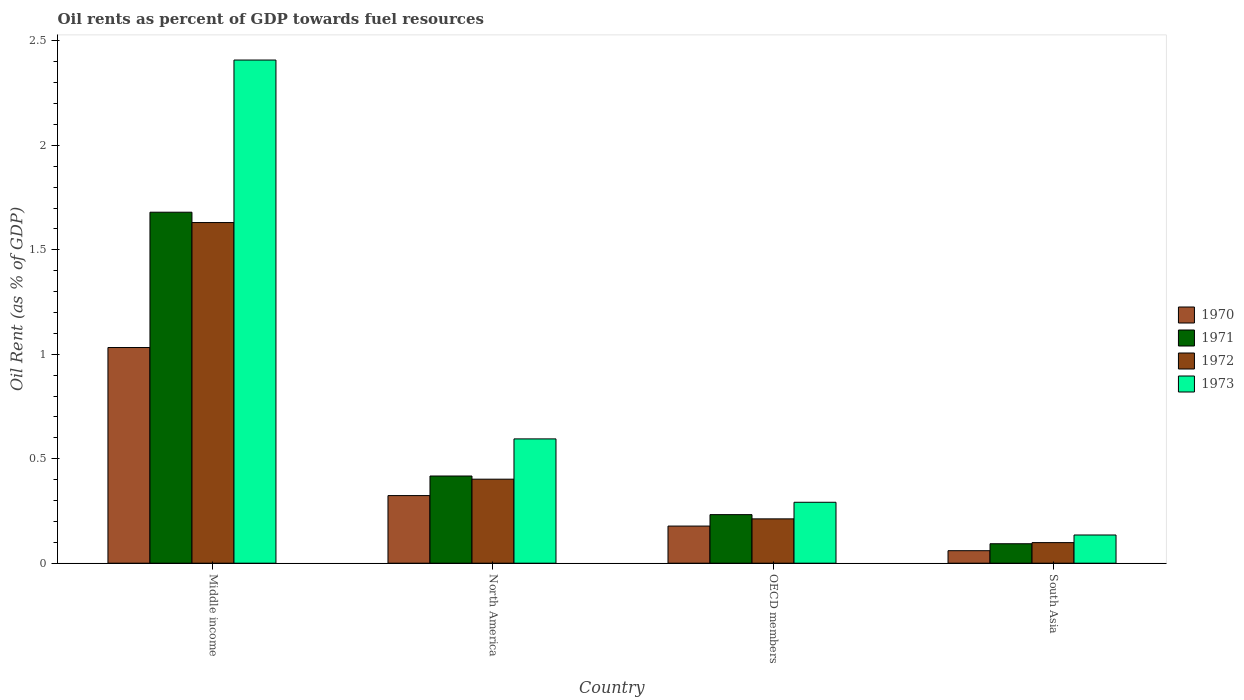Are the number of bars per tick equal to the number of legend labels?
Ensure brevity in your answer.  Yes. Are the number of bars on each tick of the X-axis equal?
Keep it short and to the point. Yes. How many bars are there on the 1st tick from the left?
Your response must be concise. 4. In how many cases, is the number of bars for a given country not equal to the number of legend labels?
Your response must be concise. 0. What is the oil rent in 1972 in North America?
Your answer should be compact. 0.4. Across all countries, what is the maximum oil rent in 1973?
Keep it short and to the point. 2.41. Across all countries, what is the minimum oil rent in 1972?
Make the answer very short. 0.1. In which country was the oil rent in 1973 maximum?
Keep it short and to the point. Middle income. In which country was the oil rent in 1973 minimum?
Provide a succinct answer. South Asia. What is the total oil rent in 1971 in the graph?
Your response must be concise. 2.42. What is the difference between the oil rent in 1973 in OECD members and that in South Asia?
Offer a terse response. 0.16. What is the difference between the oil rent in 1973 in North America and the oil rent in 1972 in South Asia?
Your answer should be very brief. 0.5. What is the average oil rent in 1972 per country?
Make the answer very short. 0.59. What is the difference between the oil rent of/in 1970 and oil rent of/in 1971 in North America?
Your response must be concise. -0.09. What is the ratio of the oil rent in 1973 in Middle income to that in South Asia?
Keep it short and to the point. 17.84. Is the difference between the oil rent in 1970 in OECD members and South Asia greater than the difference between the oil rent in 1971 in OECD members and South Asia?
Keep it short and to the point. No. What is the difference between the highest and the second highest oil rent in 1970?
Make the answer very short. -0.71. What is the difference between the highest and the lowest oil rent in 1970?
Provide a succinct answer. 0.97. Is the sum of the oil rent in 1971 in Middle income and North America greater than the maximum oil rent in 1973 across all countries?
Offer a very short reply. No. Is it the case that in every country, the sum of the oil rent in 1972 and oil rent in 1970 is greater than the oil rent in 1973?
Give a very brief answer. Yes. What is the difference between two consecutive major ticks on the Y-axis?
Ensure brevity in your answer.  0.5. Are the values on the major ticks of Y-axis written in scientific E-notation?
Ensure brevity in your answer.  No. What is the title of the graph?
Your answer should be compact. Oil rents as percent of GDP towards fuel resources. Does "1983" appear as one of the legend labels in the graph?
Give a very brief answer. No. What is the label or title of the X-axis?
Your answer should be compact. Country. What is the label or title of the Y-axis?
Your response must be concise. Oil Rent (as % of GDP). What is the Oil Rent (as % of GDP) of 1970 in Middle income?
Give a very brief answer. 1.03. What is the Oil Rent (as % of GDP) in 1971 in Middle income?
Provide a short and direct response. 1.68. What is the Oil Rent (as % of GDP) of 1972 in Middle income?
Keep it short and to the point. 1.63. What is the Oil Rent (as % of GDP) in 1973 in Middle income?
Give a very brief answer. 2.41. What is the Oil Rent (as % of GDP) of 1970 in North America?
Ensure brevity in your answer.  0.32. What is the Oil Rent (as % of GDP) of 1971 in North America?
Your answer should be compact. 0.42. What is the Oil Rent (as % of GDP) of 1972 in North America?
Keep it short and to the point. 0.4. What is the Oil Rent (as % of GDP) in 1973 in North America?
Your answer should be compact. 0.6. What is the Oil Rent (as % of GDP) in 1970 in OECD members?
Give a very brief answer. 0.18. What is the Oil Rent (as % of GDP) of 1971 in OECD members?
Your answer should be compact. 0.23. What is the Oil Rent (as % of GDP) of 1972 in OECD members?
Keep it short and to the point. 0.21. What is the Oil Rent (as % of GDP) of 1973 in OECD members?
Keep it short and to the point. 0.29. What is the Oil Rent (as % of GDP) in 1970 in South Asia?
Your answer should be very brief. 0.06. What is the Oil Rent (as % of GDP) in 1971 in South Asia?
Offer a very short reply. 0.09. What is the Oil Rent (as % of GDP) in 1972 in South Asia?
Keep it short and to the point. 0.1. What is the Oil Rent (as % of GDP) of 1973 in South Asia?
Provide a succinct answer. 0.14. Across all countries, what is the maximum Oil Rent (as % of GDP) of 1970?
Your answer should be very brief. 1.03. Across all countries, what is the maximum Oil Rent (as % of GDP) in 1971?
Make the answer very short. 1.68. Across all countries, what is the maximum Oil Rent (as % of GDP) of 1972?
Offer a terse response. 1.63. Across all countries, what is the maximum Oil Rent (as % of GDP) in 1973?
Provide a succinct answer. 2.41. Across all countries, what is the minimum Oil Rent (as % of GDP) of 1970?
Make the answer very short. 0.06. Across all countries, what is the minimum Oil Rent (as % of GDP) of 1971?
Give a very brief answer. 0.09. Across all countries, what is the minimum Oil Rent (as % of GDP) in 1972?
Make the answer very short. 0.1. Across all countries, what is the minimum Oil Rent (as % of GDP) in 1973?
Provide a succinct answer. 0.14. What is the total Oil Rent (as % of GDP) in 1970 in the graph?
Offer a terse response. 1.59. What is the total Oil Rent (as % of GDP) in 1971 in the graph?
Give a very brief answer. 2.42. What is the total Oil Rent (as % of GDP) in 1972 in the graph?
Make the answer very short. 2.34. What is the total Oil Rent (as % of GDP) of 1973 in the graph?
Your answer should be compact. 3.43. What is the difference between the Oil Rent (as % of GDP) in 1970 in Middle income and that in North America?
Your answer should be compact. 0.71. What is the difference between the Oil Rent (as % of GDP) in 1971 in Middle income and that in North America?
Provide a succinct answer. 1.26. What is the difference between the Oil Rent (as % of GDP) of 1972 in Middle income and that in North America?
Offer a very short reply. 1.23. What is the difference between the Oil Rent (as % of GDP) of 1973 in Middle income and that in North America?
Provide a short and direct response. 1.81. What is the difference between the Oil Rent (as % of GDP) in 1970 in Middle income and that in OECD members?
Ensure brevity in your answer.  0.85. What is the difference between the Oil Rent (as % of GDP) in 1971 in Middle income and that in OECD members?
Provide a succinct answer. 1.45. What is the difference between the Oil Rent (as % of GDP) of 1972 in Middle income and that in OECD members?
Give a very brief answer. 1.42. What is the difference between the Oil Rent (as % of GDP) of 1973 in Middle income and that in OECD members?
Provide a short and direct response. 2.12. What is the difference between the Oil Rent (as % of GDP) in 1970 in Middle income and that in South Asia?
Keep it short and to the point. 0.97. What is the difference between the Oil Rent (as % of GDP) in 1971 in Middle income and that in South Asia?
Provide a short and direct response. 1.59. What is the difference between the Oil Rent (as % of GDP) of 1972 in Middle income and that in South Asia?
Give a very brief answer. 1.53. What is the difference between the Oil Rent (as % of GDP) of 1973 in Middle income and that in South Asia?
Offer a terse response. 2.27. What is the difference between the Oil Rent (as % of GDP) of 1970 in North America and that in OECD members?
Provide a short and direct response. 0.15. What is the difference between the Oil Rent (as % of GDP) in 1971 in North America and that in OECD members?
Offer a very short reply. 0.18. What is the difference between the Oil Rent (as % of GDP) in 1972 in North America and that in OECD members?
Make the answer very short. 0.19. What is the difference between the Oil Rent (as % of GDP) of 1973 in North America and that in OECD members?
Your response must be concise. 0.3. What is the difference between the Oil Rent (as % of GDP) in 1970 in North America and that in South Asia?
Offer a very short reply. 0.26. What is the difference between the Oil Rent (as % of GDP) in 1971 in North America and that in South Asia?
Your response must be concise. 0.32. What is the difference between the Oil Rent (as % of GDP) of 1972 in North America and that in South Asia?
Provide a short and direct response. 0.3. What is the difference between the Oil Rent (as % of GDP) in 1973 in North America and that in South Asia?
Offer a terse response. 0.46. What is the difference between the Oil Rent (as % of GDP) of 1970 in OECD members and that in South Asia?
Your answer should be compact. 0.12. What is the difference between the Oil Rent (as % of GDP) in 1971 in OECD members and that in South Asia?
Your response must be concise. 0.14. What is the difference between the Oil Rent (as % of GDP) in 1972 in OECD members and that in South Asia?
Your answer should be very brief. 0.11. What is the difference between the Oil Rent (as % of GDP) of 1973 in OECD members and that in South Asia?
Provide a short and direct response. 0.16. What is the difference between the Oil Rent (as % of GDP) in 1970 in Middle income and the Oil Rent (as % of GDP) in 1971 in North America?
Your answer should be compact. 0.61. What is the difference between the Oil Rent (as % of GDP) of 1970 in Middle income and the Oil Rent (as % of GDP) of 1972 in North America?
Your response must be concise. 0.63. What is the difference between the Oil Rent (as % of GDP) in 1970 in Middle income and the Oil Rent (as % of GDP) in 1973 in North America?
Ensure brevity in your answer.  0.44. What is the difference between the Oil Rent (as % of GDP) in 1971 in Middle income and the Oil Rent (as % of GDP) in 1972 in North America?
Provide a succinct answer. 1.28. What is the difference between the Oil Rent (as % of GDP) in 1971 in Middle income and the Oil Rent (as % of GDP) in 1973 in North America?
Make the answer very short. 1.09. What is the difference between the Oil Rent (as % of GDP) of 1972 in Middle income and the Oil Rent (as % of GDP) of 1973 in North America?
Your answer should be very brief. 1.04. What is the difference between the Oil Rent (as % of GDP) of 1970 in Middle income and the Oil Rent (as % of GDP) of 1971 in OECD members?
Your response must be concise. 0.8. What is the difference between the Oil Rent (as % of GDP) in 1970 in Middle income and the Oil Rent (as % of GDP) in 1972 in OECD members?
Offer a very short reply. 0.82. What is the difference between the Oil Rent (as % of GDP) in 1970 in Middle income and the Oil Rent (as % of GDP) in 1973 in OECD members?
Offer a very short reply. 0.74. What is the difference between the Oil Rent (as % of GDP) in 1971 in Middle income and the Oil Rent (as % of GDP) in 1972 in OECD members?
Make the answer very short. 1.47. What is the difference between the Oil Rent (as % of GDP) in 1971 in Middle income and the Oil Rent (as % of GDP) in 1973 in OECD members?
Provide a succinct answer. 1.39. What is the difference between the Oil Rent (as % of GDP) of 1972 in Middle income and the Oil Rent (as % of GDP) of 1973 in OECD members?
Your answer should be compact. 1.34. What is the difference between the Oil Rent (as % of GDP) in 1970 in Middle income and the Oil Rent (as % of GDP) in 1971 in South Asia?
Offer a terse response. 0.94. What is the difference between the Oil Rent (as % of GDP) in 1970 in Middle income and the Oil Rent (as % of GDP) in 1972 in South Asia?
Make the answer very short. 0.93. What is the difference between the Oil Rent (as % of GDP) in 1970 in Middle income and the Oil Rent (as % of GDP) in 1973 in South Asia?
Your answer should be very brief. 0.9. What is the difference between the Oil Rent (as % of GDP) of 1971 in Middle income and the Oil Rent (as % of GDP) of 1972 in South Asia?
Offer a terse response. 1.58. What is the difference between the Oil Rent (as % of GDP) of 1971 in Middle income and the Oil Rent (as % of GDP) of 1973 in South Asia?
Keep it short and to the point. 1.55. What is the difference between the Oil Rent (as % of GDP) of 1972 in Middle income and the Oil Rent (as % of GDP) of 1973 in South Asia?
Make the answer very short. 1.5. What is the difference between the Oil Rent (as % of GDP) in 1970 in North America and the Oil Rent (as % of GDP) in 1971 in OECD members?
Ensure brevity in your answer.  0.09. What is the difference between the Oil Rent (as % of GDP) in 1970 in North America and the Oil Rent (as % of GDP) in 1972 in OECD members?
Ensure brevity in your answer.  0.11. What is the difference between the Oil Rent (as % of GDP) in 1970 in North America and the Oil Rent (as % of GDP) in 1973 in OECD members?
Offer a very short reply. 0.03. What is the difference between the Oil Rent (as % of GDP) in 1971 in North America and the Oil Rent (as % of GDP) in 1972 in OECD members?
Offer a very short reply. 0.21. What is the difference between the Oil Rent (as % of GDP) of 1971 in North America and the Oil Rent (as % of GDP) of 1973 in OECD members?
Your answer should be very brief. 0.13. What is the difference between the Oil Rent (as % of GDP) in 1972 in North America and the Oil Rent (as % of GDP) in 1973 in OECD members?
Offer a terse response. 0.11. What is the difference between the Oil Rent (as % of GDP) of 1970 in North America and the Oil Rent (as % of GDP) of 1971 in South Asia?
Provide a short and direct response. 0.23. What is the difference between the Oil Rent (as % of GDP) in 1970 in North America and the Oil Rent (as % of GDP) in 1972 in South Asia?
Offer a very short reply. 0.23. What is the difference between the Oil Rent (as % of GDP) of 1970 in North America and the Oil Rent (as % of GDP) of 1973 in South Asia?
Your answer should be very brief. 0.19. What is the difference between the Oil Rent (as % of GDP) of 1971 in North America and the Oil Rent (as % of GDP) of 1972 in South Asia?
Give a very brief answer. 0.32. What is the difference between the Oil Rent (as % of GDP) of 1971 in North America and the Oil Rent (as % of GDP) of 1973 in South Asia?
Your answer should be compact. 0.28. What is the difference between the Oil Rent (as % of GDP) of 1972 in North America and the Oil Rent (as % of GDP) of 1973 in South Asia?
Your answer should be compact. 0.27. What is the difference between the Oil Rent (as % of GDP) in 1970 in OECD members and the Oil Rent (as % of GDP) in 1971 in South Asia?
Ensure brevity in your answer.  0.08. What is the difference between the Oil Rent (as % of GDP) in 1970 in OECD members and the Oil Rent (as % of GDP) in 1972 in South Asia?
Ensure brevity in your answer.  0.08. What is the difference between the Oil Rent (as % of GDP) of 1970 in OECD members and the Oil Rent (as % of GDP) of 1973 in South Asia?
Give a very brief answer. 0.04. What is the difference between the Oil Rent (as % of GDP) of 1971 in OECD members and the Oil Rent (as % of GDP) of 1972 in South Asia?
Provide a succinct answer. 0.13. What is the difference between the Oil Rent (as % of GDP) in 1971 in OECD members and the Oil Rent (as % of GDP) in 1973 in South Asia?
Keep it short and to the point. 0.1. What is the difference between the Oil Rent (as % of GDP) of 1972 in OECD members and the Oil Rent (as % of GDP) of 1973 in South Asia?
Offer a very short reply. 0.08. What is the average Oil Rent (as % of GDP) in 1970 per country?
Offer a terse response. 0.4. What is the average Oil Rent (as % of GDP) in 1971 per country?
Give a very brief answer. 0.61. What is the average Oil Rent (as % of GDP) of 1972 per country?
Your answer should be very brief. 0.59. What is the average Oil Rent (as % of GDP) in 1973 per country?
Provide a succinct answer. 0.86. What is the difference between the Oil Rent (as % of GDP) of 1970 and Oil Rent (as % of GDP) of 1971 in Middle income?
Give a very brief answer. -0.65. What is the difference between the Oil Rent (as % of GDP) of 1970 and Oil Rent (as % of GDP) of 1972 in Middle income?
Offer a terse response. -0.6. What is the difference between the Oil Rent (as % of GDP) of 1970 and Oil Rent (as % of GDP) of 1973 in Middle income?
Make the answer very short. -1.38. What is the difference between the Oil Rent (as % of GDP) in 1971 and Oil Rent (as % of GDP) in 1972 in Middle income?
Your answer should be very brief. 0.05. What is the difference between the Oil Rent (as % of GDP) of 1971 and Oil Rent (as % of GDP) of 1973 in Middle income?
Ensure brevity in your answer.  -0.73. What is the difference between the Oil Rent (as % of GDP) in 1972 and Oil Rent (as % of GDP) in 1973 in Middle income?
Provide a succinct answer. -0.78. What is the difference between the Oil Rent (as % of GDP) in 1970 and Oil Rent (as % of GDP) in 1971 in North America?
Keep it short and to the point. -0.09. What is the difference between the Oil Rent (as % of GDP) in 1970 and Oil Rent (as % of GDP) in 1972 in North America?
Your answer should be very brief. -0.08. What is the difference between the Oil Rent (as % of GDP) of 1970 and Oil Rent (as % of GDP) of 1973 in North America?
Keep it short and to the point. -0.27. What is the difference between the Oil Rent (as % of GDP) in 1971 and Oil Rent (as % of GDP) in 1972 in North America?
Offer a very short reply. 0.02. What is the difference between the Oil Rent (as % of GDP) in 1971 and Oil Rent (as % of GDP) in 1973 in North America?
Keep it short and to the point. -0.18. What is the difference between the Oil Rent (as % of GDP) in 1972 and Oil Rent (as % of GDP) in 1973 in North America?
Your response must be concise. -0.19. What is the difference between the Oil Rent (as % of GDP) in 1970 and Oil Rent (as % of GDP) in 1971 in OECD members?
Offer a very short reply. -0.05. What is the difference between the Oil Rent (as % of GDP) of 1970 and Oil Rent (as % of GDP) of 1972 in OECD members?
Ensure brevity in your answer.  -0.03. What is the difference between the Oil Rent (as % of GDP) in 1970 and Oil Rent (as % of GDP) in 1973 in OECD members?
Give a very brief answer. -0.11. What is the difference between the Oil Rent (as % of GDP) of 1971 and Oil Rent (as % of GDP) of 1972 in OECD members?
Provide a succinct answer. 0.02. What is the difference between the Oil Rent (as % of GDP) in 1971 and Oil Rent (as % of GDP) in 1973 in OECD members?
Offer a terse response. -0.06. What is the difference between the Oil Rent (as % of GDP) of 1972 and Oil Rent (as % of GDP) of 1973 in OECD members?
Your answer should be very brief. -0.08. What is the difference between the Oil Rent (as % of GDP) in 1970 and Oil Rent (as % of GDP) in 1971 in South Asia?
Ensure brevity in your answer.  -0.03. What is the difference between the Oil Rent (as % of GDP) in 1970 and Oil Rent (as % of GDP) in 1972 in South Asia?
Make the answer very short. -0.04. What is the difference between the Oil Rent (as % of GDP) of 1970 and Oil Rent (as % of GDP) of 1973 in South Asia?
Give a very brief answer. -0.08. What is the difference between the Oil Rent (as % of GDP) of 1971 and Oil Rent (as % of GDP) of 1972 in South Asia?
Give a very brief answer. -0.01. What is the difference between the Oil Rent (as % of GDP) of 1971 and Oil Rent (as % of GDP) of 1973 in South Asia?
Give a very brief answer. -0.04. What is the difference between the Oil Rent (as % of GDP) of 1972 and Oil Rent (as % of GDP) of 1973 in South Asia?
Make the answer very short. -0.04. What is the ratio of the Oil Rent (as % of GDP) in 1970 in Middle income to that in North America?
Provide a short and direct response. 3.19. What is the ratio of the Oil Rent (as % of GDP) in 1971 in Middle income to that in North America?
Your answer should be compact. 4.03. What is the ratio of the Oil Rent (as % of GDP) in 1972 in Middle income to that in North America?
Offer a terse response. 4.05. What is the ratio of the Oil Rent (as % of GDP) in 1973 in Middle income to that in North America?
Your response must be concise. 4.05. What is the ratio of the Oil Rent (as % of GDP) in 1970 in Middle income to that in OECD members?
Offer a very short reply. 5.81. What is the ratio of the Oil Rent (as % of GDP) of 1971 in Middle income to that in OECD members?
Ensure brevity in your answer.  7.23. What is the ratio of the Oil Rent (as % of GDP) in 1972 in Middle income to that in OECD members?
Offer a very short reply. 7.68. What is the ratio of the Oil Rent (as % of GDP) of 1973 in Middle income to that in OECD members?
Give a very brief answer. 8.26. What is the ratio of the Oil Rent (as % of GDP) in 1970 in Middle income to that in South Asia?
Your answer should be very brief. 17.23. What is the ratio of the Oil Rent (as % of GDP) in 1971 in Middle income to that in South Asia?
Provide a succinct answer. 18.04. What is the ratio of the Oil Rent (as % of GDP) in 1972 in Middle income to that in South Asia?
Your response must be concise. 16.55. What is the ratio of the Oil Rent (as % of GDP) of 1973 in Middle income to that in South Asia?
Your response must be concise. 17.84. What is the ratio of the Oil Rent (as % of GDP) in 1970 in North America to that in OECD members?
Ensure brevity in your answer.  1.82. What is the ratio of the Oil Rent (as % of GDP) of 1971 in North America to that in OECD members?
Offer a very short reply. 1.8. What is the ratio of the Oil Rent (as % of GDP) of 1972 in North America to that in OECD members?
Provide a short and direct response. 1.9. What is the ratio of the Oil Rent (as % of GDP) in 1973 in North America to that in OECD members?
Give a very brief answer. 2.04. What is the ratio of the Oil Rent (as % of GDP) in 1970 in North America to that in South Asia?
Your answer should be compact. 5.4. What is the ratio of the Oil Rent (as % of GDP) in 1971 in North America to that in South Asia?
Provide a succinct answer. 4.48. What is the ratio of the Oil Rent (as % of GDP) of 1972 in North America to that in South Asia?
Your answer should be very brief. 4.08. What is the ratio of the Oil Rent (as % of GDP) in 1973 in North America to that in South Asia?
Your answer should be very brief. 4.41. What is the ratio of the Oil Rent (as % of GDP) of 1970 in OECD members to that in South Asia?
Provide a short and direct response. 2.97. What is the ratio of the Oil Rent (as % of GDP) in 1971 in OECD members to that in South Asia?
Offer a terse response. 2.5. What is the ratio of the Oil Rent (as % of GDP) of 1972 in OECD members to that in South Asia?
Provide a short and direct response. 2.15. What is the ratio of the Oil Rent (as % of GDP) in 1973 in OECD members to that in South Asia?
Your answer should be compact. 2.16. What is the difference between the highest and the second highest Oil Rent (as % of GDP) in 1970?
Provide a short and direct response. 0.71. What is the difference between the highest and the second highest Oil Rent (as % of GDP) in 1971?
Provide a succinct answer. 1.26. What is the difference between the highest and the second highest Oil Rent (as % of GDP) in 1972?
Your answer should be very brief. 1.23. What is the difference between the highest and the second highest Oil Rent (as % of GDP) in 1973?
Keep it short and to the point. 1.81. What is the difference between the highest and the lowest Oil Rent (as % of GDP) in 1970?
Your answer should be very brief. 0.97. What is the difference between the highest and the lowest Oil Rent (as % of GDP) in 1971?
Make the answer very short. 1.59. What is the difference between the highest and the lowest Oil Rent (as % of GDP) in 1972?
Offer a very short reply. 1.53. What is the difference between the highest and the lowest Oil Rent (as % of GDP) of 1973?
Your answer should be compact. 2.27. 